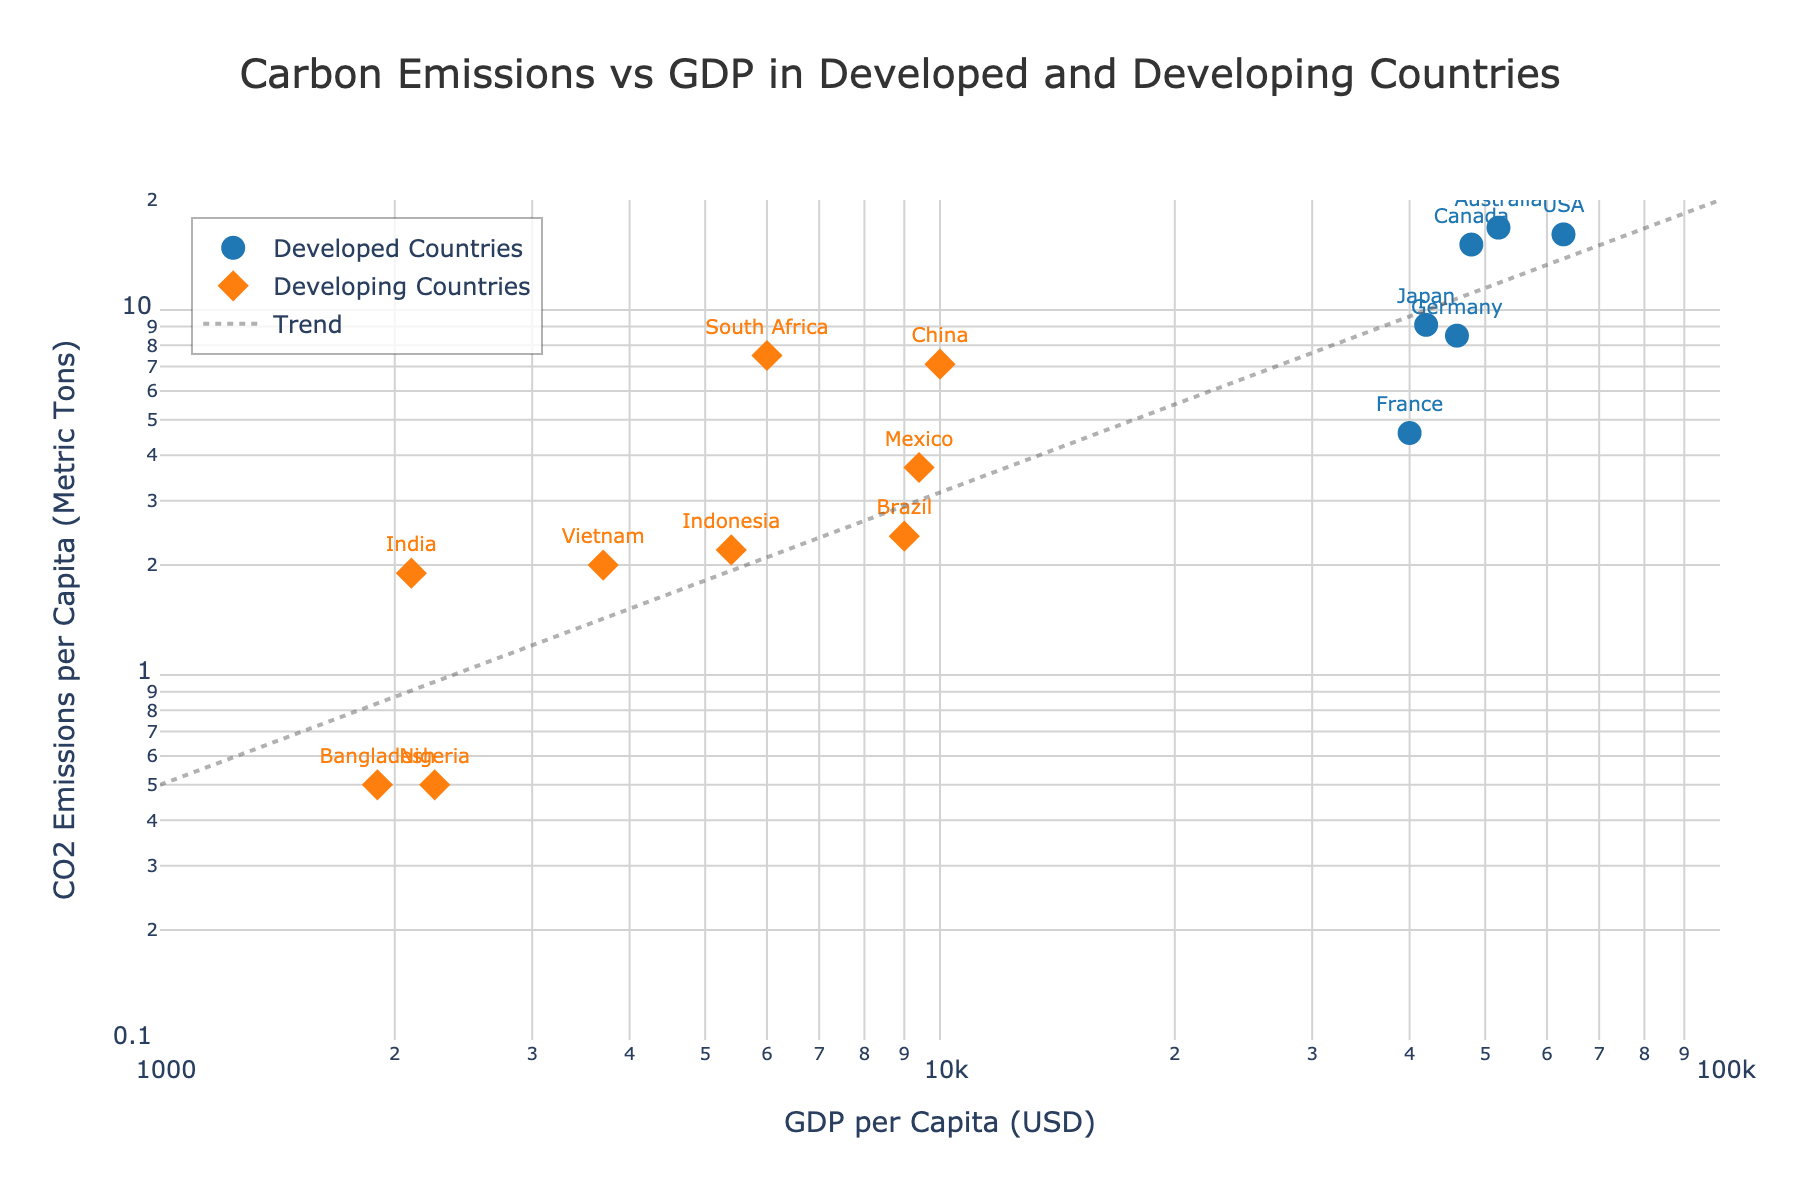What is the title of the scatter plot? The title of the scatter plot is located at the top center. It reads 'Carbon Emissions vs GDP in Developed and Developing Countries'.
Answer: Carbon Emissions vs GDP in Developed and Developing Countries Which axis represents GDP per Capita? The x-axis represents GDP per Capita, which is labeled as 'GDP per Capita (USD)'.
Answer: x-axis What do the different colors of the markers represent? The scatter plot uses different colors to distinguish between developed and developing countries. Blue represents developed countries, and orange represents developing countries.
Answer: Developed countries (blue) and developing countries (orange) How would you describe the trend line included in the plot? The trend line seems to indicate a positive relationship between GDP per Capita and CO2 Emissions per Capita, as it slopes upwards from the bottom-left to the top-right.
Answer: Positive relationship Which country has the highest GDP per Capita? By locating the furthest point to the right on the x-axis, the USA has the highest GDP per Capita at 63,000 USD.
Answer: USA Which developed country has the lowest CO2 Emissions per Capita? Looking at the blue markers for developed countries, France has the lowest CO2 Emissions per Capita at 4.6 metric tons.
Answer: France Compare the CO2 Emissions per Capita for China and India. Which country has higher emissions? China has a CO2 Emissions per Capita of 7.1 metric tons while India has 1.9 metric tons. Therefore, China has higher emissions.
Answer: China What is the range of CO2 Emissions per Capita for developing countries? Observing the orange markers, the CO2 Emissions per Capita for developing countries range from 0.5 metric tons (Nigeria, Bangladesh) to 7.5 metric tons (South Africa).
Answer: 0.5 to 7.5 metric tons By observing the plot, do developed countries generally have higher GDP per Capita and CO2 Emissions per Capita compared to developing countries? Yes, developed countries (blue markers) generally display higher values on both the x-axis (GDP per Capita) and y-axis (CO2 Emissions per Capita) compared to developing countries (orange markers).
Answer: Yes 